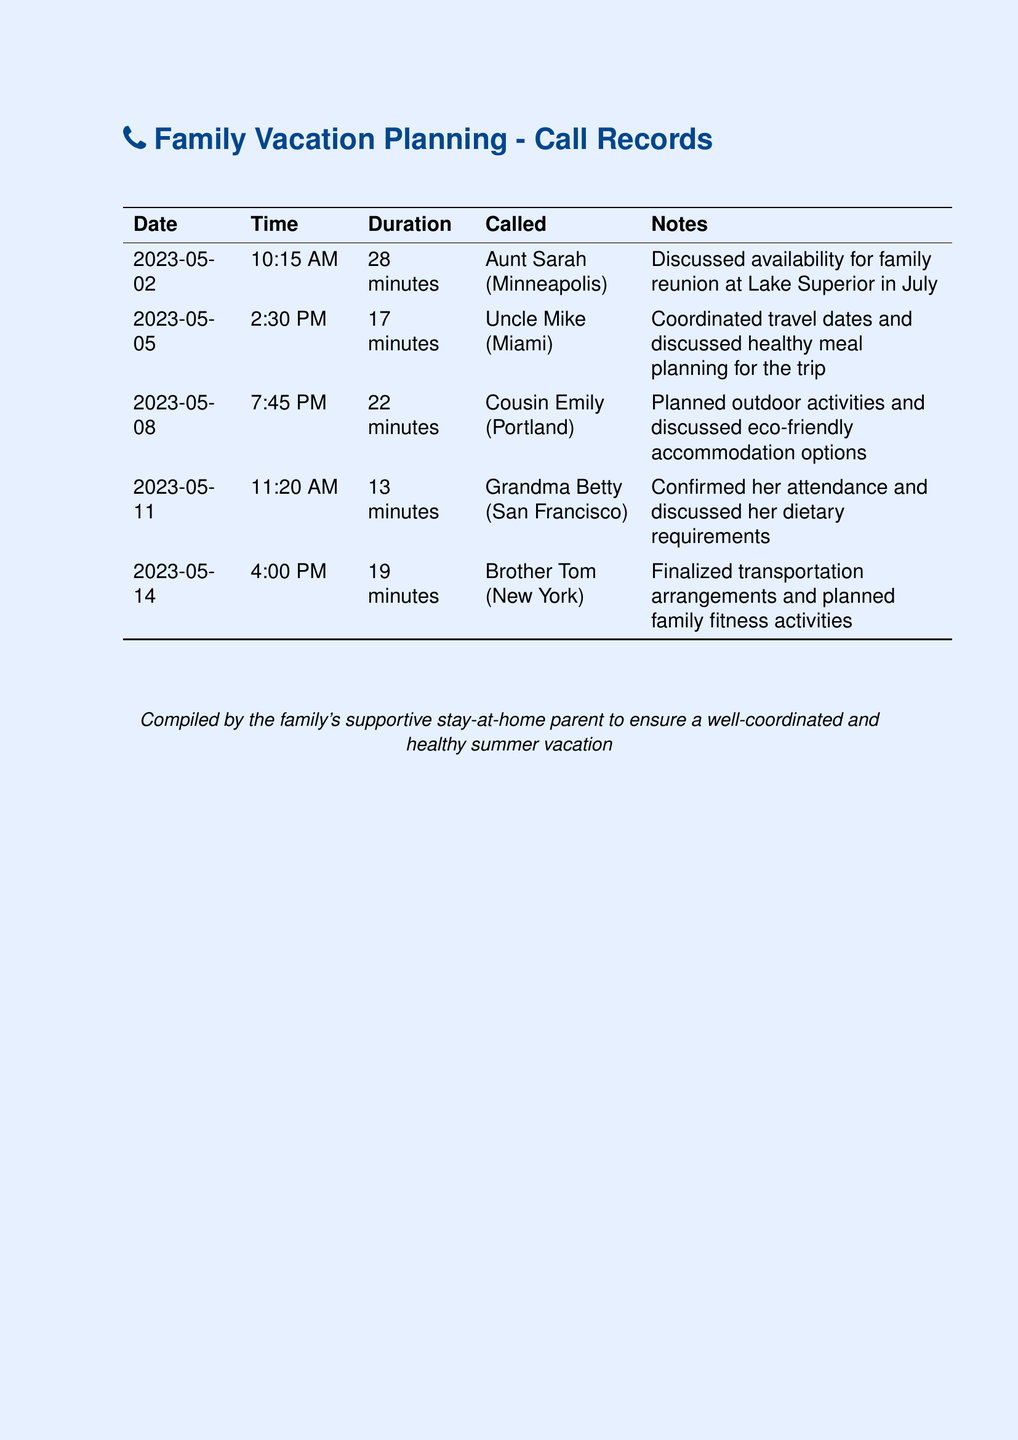what is the date of the call with Aunt Sarah? The document states that the call with Aunt Sarah took place on May 2, 2023.
Answer: May 2, 2023 how long was the call with Uncle Mike? According to the document, the duration of the call with Uncle Mike was 17 minutes.
Answer: 17 minutes who did the caller discuss dietary requirements with? The caller discussed dietary requirements with Grandma Betty.
Answer: Grandma Betty which family member was called on May 11? The document records that Brother Tom was called on May 11.
Answer: Brother Tom what activity was planned during the call with Cousin Emily? The call with Cousin Emily involved planning outdoor activities.
Answer: outdoor activities how many calls are recorded in total? The document lists a total of five calls made to family members.
Answer: five what location was mentioned for the family reunion? The location mentioned for the family reunion is Lake Superior.
Answer: Lake Superior what time did the call with Grandma Betty take place? The document indicates that the call with Grandma Betty occurred at 11:20 AM.
Answer: 11:20 AM what was one topic discussed during the call with Uncle Mike? The call with Uncle Mike included discussing healthy meal planning for the trip.
Answer: healthy meal planning 